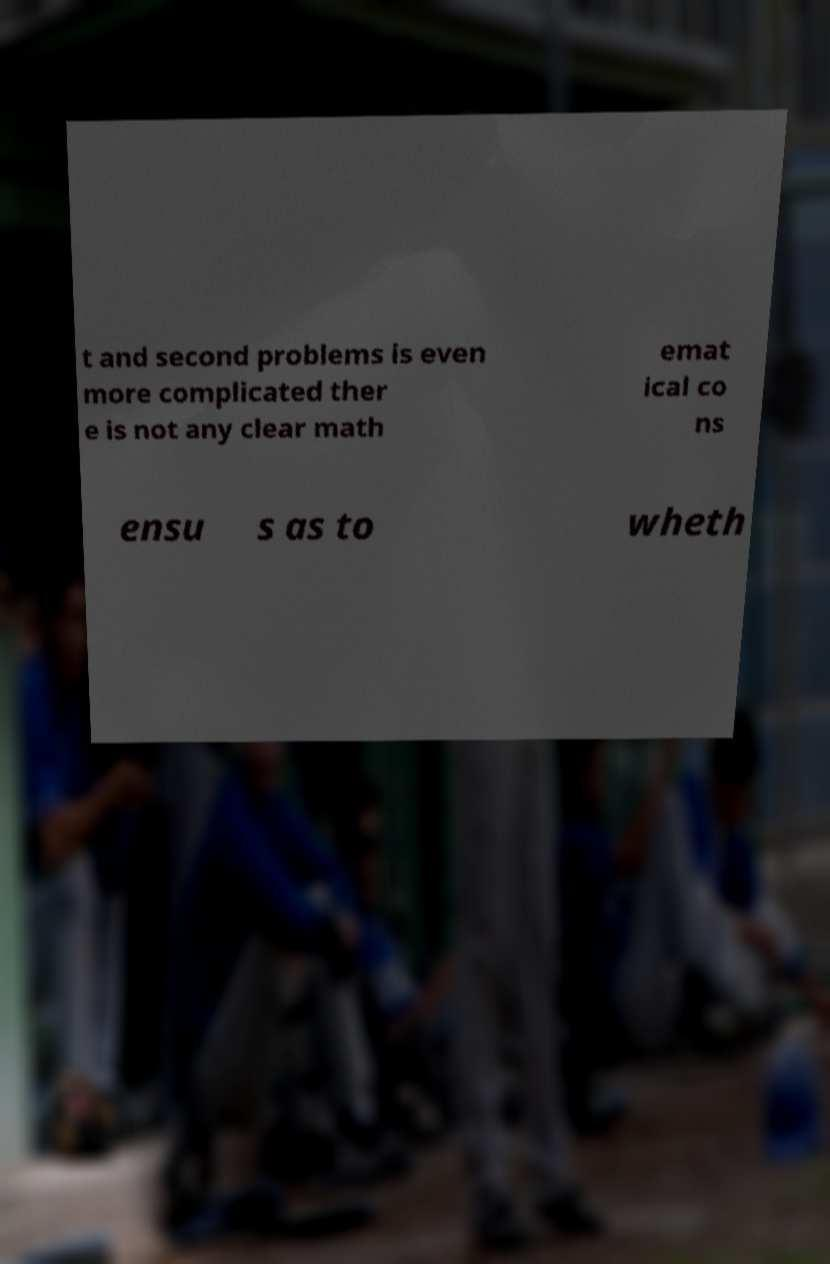Can you read and provide the text displayed in the image?This photo seems to have some interesting text. Can you extract and type it out for me? t and second problems is even more complicated ther e is not any clear math emat ical co ns ensu s as to wheth 